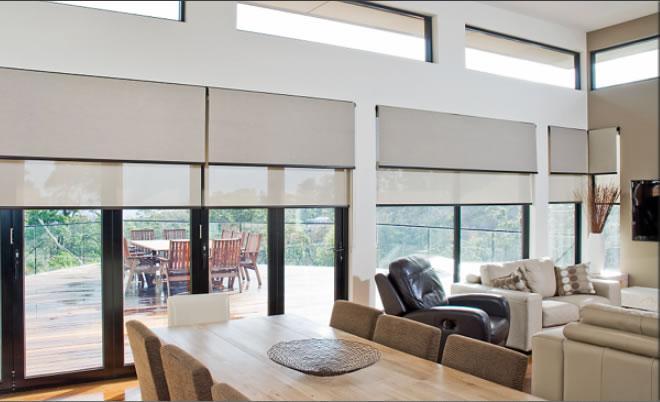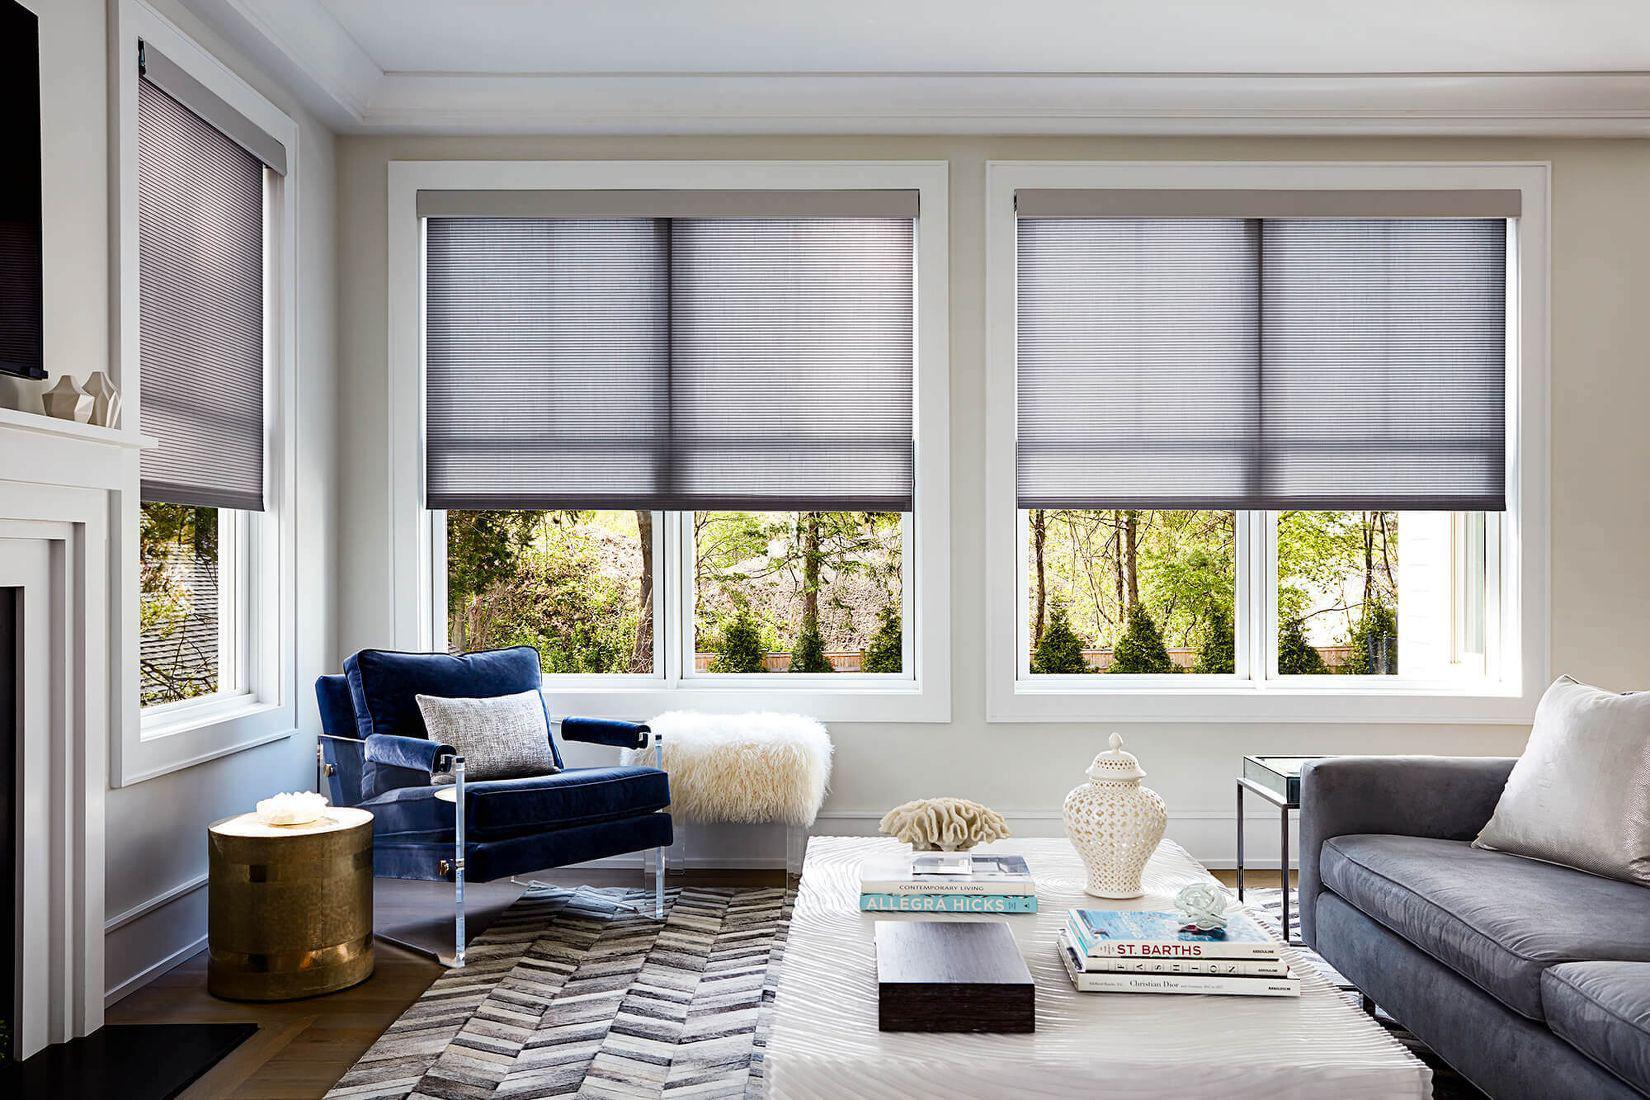The first image is the image on the left, the second image is the image on the right. Considering the images on both sides, is "All of the blinds in each image are open at equal lengths to the others in the same image." valid? Answer yes or no. Yes. 